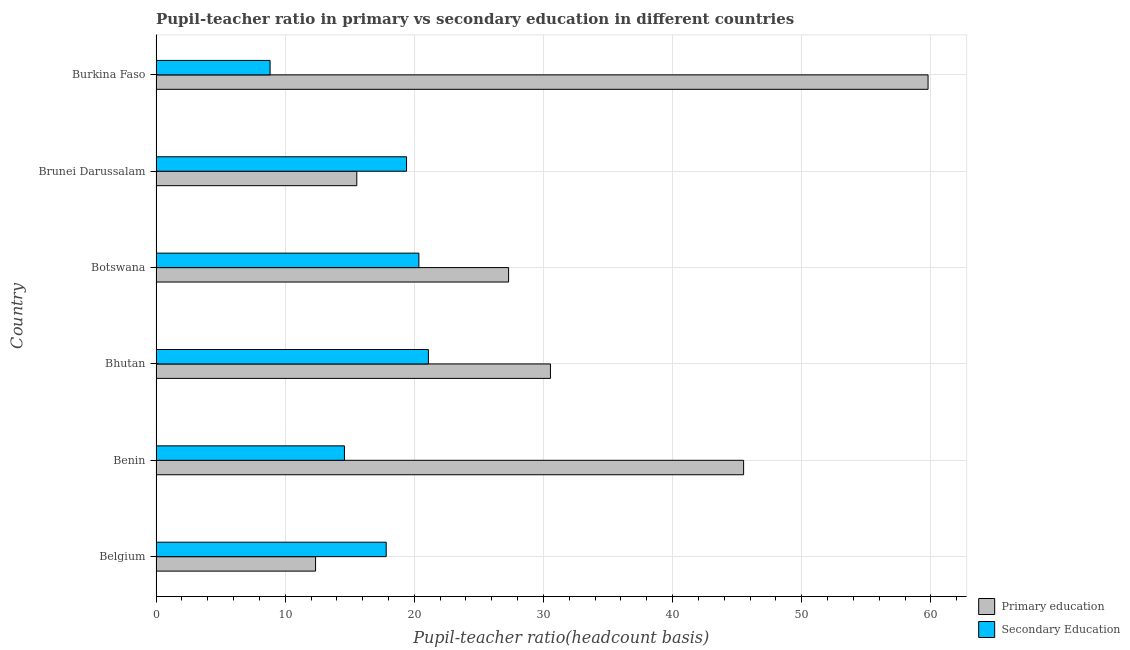Are the number of bars per tick equal to the number of legend labels?
Provide a succinct answer. Yes. Are the number of bars on each tick of the Y-axis equal?
Your response must be concise. Yes. How many bars are there on the 2nd tick from the top?
Make the answer very short. 2. What is the pupil teacher ratio on secondary education in Benin?
Keep it short and to the point. 14.59. Across all countries, what is the maximum pupil teacher ratio on secondary education?
Your response must be concise. 21.09. Across all countries, what is the minimum pupil teacher ratio on secondary education?
Provide a short and direct response. 8.83. In which country was the pupil-teacher ratio in primary education maximum?
Ensure brevity in your answer.  Burkina Faso. In which country was the pupil-teacher ratio in primary education minimum?
Keep it short and to the point. Belgium. What is the total pupil teacher ratio on secondary education in the graph?
Provide a succinct answer. 102.09. What is the difference between the pupil-teacher ratio in primary education in Bhutan and that in Brunei Darussalam?
Make the answer very short. 14.99. What is the difference between the pupil-teacher ratio in primary education in Botswana and the pupil teacher ratio on secondary education in Bhutan?
Offer a terse response. 6.21. What is the average pupil-teacher ratio in primary education per country?
Offer a very short reply. 31.84. What is the difference between the pupil teacher ratio on secondary education and pupil-teacher ratio in primary education in Bhutan?
Offer a terse response. -9.45. What is the ratio of the pupil teacher ratio on secondary education in Benin to that in Botswana?
Your answer should be compact. 0.72. Is the pupil teacher ratio on secondary education in Benin less than that in Brunei Darussalam?
Your answer should be compact. Yes. What is the difference between the highest and the second highest pupil-teacher ratio in primary education?
Offer a very short reply. 14.28. What is the difference between the highest and the lowest pupil-teacher ratio in primary education?
Provide a short and direct response. 47.43. Is the sum of the pupil-teacher ratio in primary education in Belgium and Benin greater than the maximum pupil teacher ratio on secondary education across all countries?
Offer a terse response. Yes. What does the 2nd bar from the top in Botswana represents?
Give a very brief answer. Primary education. What does the 2nd bar from the bottom in Belgium represents?
Your response must be concise. Secondary Education. What is the difference between two consecutive major ticks on the X-axis?
Provide a succinct answer. 10. Are the values on the major ticks of X-axis written in scientific E-notation?
Offer a very short reply. No. Does the graph contain any zero values?
Your response must be concise. No. What is the title of the graph?
Ensure brevity in your answer.  Pupil-teacher ratio in primary vs secondary education in different countries. What is the label or title of the X-axis?
Keep it short and to the point. Pupil-teacher ratio(headcount basis). What is the label or title of the Y-axis?
Give a very brief answer. Country. What is the Pupil-teacher ratio(headcount basis) of Primary education in Belgium?
Your response must be concise. 12.35. What is the Pupil-teacher ratio(headcount basis) in Secondary Education in Belgium?
Give a very brief answer. 17.82. What is the Pupil-teacher ratio(headcount basis) in Primary education in Benin?
Offer a very short reply. 45.5. What is the Pupil-teacher ratio(headcount basis) in Secondary Education in Benin?
Your answer should be compact. 14.59. What is the Pupil-teacher ratio(headcount basis) of Primary education in Bhutan?
Your response must be concise. 30.54. What is the Pupil-teacher ratio(headcount basis) of Secondary Education in Bhutan?
Make the answer very short. 21.09. What is the Pupil-teacher ratio(headcount basis) in Primary education in Botswana?
Provide a short and direct response. 27.3. What is the Pupil-teacher ratio(headcount basis) of Secondary Education in Botswana?
Your answer should be very brief. 20.35. What is the Pupil-teacher ratio(headcount basis) of Primary education in Brunei Darussalam?
Keep it short and to the point. 15.55. What is the Pupil-teacher ratio(headcount basis) of Secondary Education in Brunei Darussalam?
Give a very brief answer. 19.4. What is the Pupil-teacher ratio(headcount basis) of Primary education in Burkina Faso?
Provide a succinct answer. 59.78. What is the Pupil-teacher ratio(headcount basis) of Secondary Education in Burkina Faso?
Provide a succinct answer. 8.83. Across all countries, what is the maximum Pupil-teacher ratio(headcount basis) in Primary education?
Give a very brief answer. 59.78. Across all countries, what is the maximum Pupil-teacher ratio(headcount basis) of Secondary Education?
Your answer should be very brief. 21.09. Across all countries, what is the minimum Pupil-teacher ratio(headcount basis) in Primary education?
Your answer should be very brief. 12.35. Across all countries, what is the minimum Pupil-teacher ratio(headcount basis) in Secondary Education?
Give a very brief answer. 8.83. What is the total Pupil-teacher ratio(headcount basis) of Primary education in the graph?
Your answer should be compact. 191.01. What is the total Pupil-teacher ratio(headcount basis) of Secondary Education in the graph?
Make the answer very short. 102.09. What is the difference between the Pupil-teacher ratio(headcount basis) of Primary education in Belgium and that in Benin?
Your answer should be very brief. -33.14. What is the difference between the Pupil-teacher ratio(headcount basis) in Secondary Education in Belgium and that in Benin?
Keep it short and to the point. 3.23. What is the difference between the Pupil-teacher ratio(headcount basis) in Primary education in Belgium and that in Bhutan?
Offer a terse response. -18.19. What is the difference between the Pupil-teacher ratio(headcount basis) in Secondary Education in Belgium and that in Bhutan?
Your answer should be very brief. -3.27. What is the difference between the Pupil-teacher ratio(headcount basis) of Primary education in Belgium and that in Botswana?
Keep it short and to the point. -14.95. What is the difference between the Pupil-teacher ratio(headcount basis) in Secondary Education in Belgium and that in Botswana?
Make the answer very short. -2.53. What is the difference between the Pupil-teacher ratio(headcount basis) in Primary education in Belgium and that in Brunei Darussalam?
Offer a terse response. -3.19. What is the difference between the Pupil-teacher ratio(headcount basis) in Secondary Education in Belgium and that in Brunei Darussalam?
Keep it short and to the point. -1.58. What is the difference between the Pupil-teacher ratio(headcount basis) of Primary education in Belgium and that in Burkina Faso?
Make the answer very short. -47.43. What is the difference between the Pupil-teacher ratio(headcount basis) of Secondary Education in Belgium and that in Burkina Faso?
Your response must be concise. 8.99. What is the difference between the Pupil-teacher ratio(headcount basis) of Primary education in Benin and that in Bhutan?
Give a very brief answer. 14.96. What is the difference between the Pupil-teacher ratio(headcount basis) of Secondary Education in Benin and that in Bhutan?
Provide a short and direct response. -6.5. What is the difference between the Pupil-teacher ratio(headcount basis) in Primary education in Benin and that in Botswana?
Ensure brevity in your answer.  18.2. What is the difference between the Pupil-teacher ratio(headcount basis) in Secondary Education in Benin and that in Botswana?
Ensure brevity in your answer.  -5.76. What is the difference between the Pupil-teacher ratio(headcount basis) of Primary education in Benin and that in Brunei Darussalam?
Provide a short and direct response. 29.95. What is the difference between the Pupil-teacher ratio(headcount basis) of Secondary Education in Benin and that in Brunei Darussalam?
Keep it short and to the point. -4.81. What is the difference between the Pupil-teacher ratio(headcount basis) in Primary education in Benin and that in Burkina Faso?
Provide a succinct answer. -14.28. What is the difference between the Pupil-teacher ratio(headcount basis) in Secondary Education in Benin and that in Burkina Faso?
Your answer should be compact. 5.76. What is the difference between the Pupil-teacher ratio(headcount basis) in Primary education in Bhutan and that in Botswana?
Ensure brevity in your answer.  3.24. What is the difference between the Pupil-teacher ratio(headcount basis) in Secondary Education in Bhutan and that in Botswana?
Keep it short and to the point. 0.74. What is the difference between the Pupil-teacher ratio(headcount basis) in Primary education in Bhutan and that in Brunei Darussalam?
Your response must be concise. 14.99. What is the difference between the Pupil-teacher ratio(headcount basis) in Secondary Education in Bhutan and that in Brunei Darussalam?
Offer a terse response. 1.69. What is the difference between the Pupil-teacher ratio(headcount basis) of Primary education in Bhutan and that in Burkina Faso?
Your answer should be compact. -29.24. What is the difference between the Pupil-teacher ratio(headcount basis) of Secondary Education in Bhutan and that in Burkina Faso?
Your answer should be compact. 12.26. What is the difference between the Pupil-teacher ratio(headcount basis) of Primary education in Botswana and that in Brunei Darussalam?
Give a very brief answer. 11.75. What is the difference between the Pupil-teacher ratio(headcount basis) of Secondary Education in Botswana and that in Brunei Darussalam?
Provide a succinct answer. 0.96. What is the difference between the Pupil-teacher ratio(headcount basis) of Primary education in Botswana and that in Burkina Faso?
Keep it short and to the point. -32.48. What is the difference between the Pupil-teacher ratio(headcount basis) in Secondary Education in Botswana and that in Burkina Faso?
Provide a succinct answer. 11.52. What is the difference between the Pupil-teacher ratio(headcount basis) in Primary education in Brunei Darussalam and that in Burkina Faso?
Your answer should be compact. -44.23. What is the difference between the Pupil-teacher ratio(headcount basis) of Secondary Education in Brunei Darussalam and that in Burkina Faso?
Offer a terse response. 10.57. What is the difference between the Pupil-teacher ratio(headcount basis) of Primary education in Belgium and the Pupil-teacher ratio(headcount basis) of Secondary Education in Benin?
Ensure brevity in your answer.  -2.24. What is the difference between the Pupil-teacher ratio(headcount basis) in Primary education in Belgium and the Pupil-teacher ratio(headcount basis) in Secondary Education in Bhutan?
Provide a succinct answer. -8.74. What is the difference between the Pupil-teacher ratio(headcount basis) in Primary education in Belgium and the Pupil-teacher ratio(headcount basis) in Secondary Education in Botswana?
Provide a short and direct response. -8. What is the difference between the Pupil-teacher ratio(headcount basis) of Primary education in Belgium and the Pupil-teacher ratio(headcount basis) of Secondary Education in Brunei Darussalam?
Your answer should be very brief. -7.05. What is the difference between the Pupil-teacher ratio(headcount basis) in Primary education in Belgium and the Pupil-teacher ratio(headcount basis) in Secondary Education in Burkina Faso?
Your response must be concise. 3.52. What is the difference between the Pupil-teacher ratio(headcount basis) in Primary education in Benin and the Pupil-teacher ratio(headcount basis) in Secondary Education in Bhutan?
Provide a succinct answer. 24.41. What is the difference between the Pupil-teacher ratio(headcount basis) in Primary education in Benin and the Pupil-teacher ratio(headcount basis) in Secondary Education in Botswana?
Provide a succinct answer. 25.14. What is the difference between the Pupil-teacher ratio(headcount basis) of Primary education in Benin and the Pupil-teacher ratio(headcount basis) of Secondary Education in Brunei Darussalam?
Keep it short and to the point. 26.1. What is the difference between the Pupil-teacher ratio(headcount basis) in Primary education in Benin and the Pupil-teacher ratio(headcount basis) in Secondary Education in Burkina Faso?
Provide a short and direct response. 36.66. What is the difference between the Pupil-teacher ratio(headcount basis) in Primary education in Bhutan and the Pupil-teacher ratio(headcount basis) in Secondary Education in Botswana?
Your response must be concise. 10.19. What is the difference between the Pupil-teacher ratio(headcount basis) of Primary education in Bhutan and the Pupil-teacher ratio(headcount basis) of Secondary Education in Brunei Darussalam?
Offer a very short reply. 11.14. What is the difference between the Pupil-teacher ratio(headcount basis) of Primary education in Bhutan and the Pupil-teacher ratio(headcount basis) of Secondary Education in Burkina Faso?
Ensure brevity in your answer.  21.71. What is the difference between the Pupil-teacher ratio(headcount basis) in Primary education in Botswana and the Pupil-teacher ratio(headcount basis) in Secondary Education in Brunei Darussalam?
Ensure brevity in your answer.  7.9. What is the difference between the Pupil-teacher ratio(headcount basis) in Primary education in Botswana and the Pupil-teacher ratio(headcount basis) in Secondary Education in Burkina Faso?
Provide a succinct answer. 18.47. What is the difference between the Pupil-teacher ratio(headcount basis) in Primary education in Brunei Darussalam and the Pupil-teacher ratio(headcount basis) in Secondary Education in Burkina Faso?
Ensure brevity in your answer.  6.71. What is the average Pupil-teacher ratio(headcount basis) of Primary education per country?
Keep it short and to the point. 31.84. What is the average Pupil-teacher ratio(headcount basis) in Secondary Education per country?
Your response must be concise. 17.01. What is the difference between the Pupil-teacher ratio(headcount basis) in Primary education and Pupil-teacher ratio(headcount basis) in Secondary Education in Belgium?
Provide a short and direct response. -5.47. What is the difference between the Pupil-teacher ratio(headcount basis) of Primary education and Pupil-teacher ratio(headcount basis) of Secondary Education in Benin?
Make the answer very short. 30.91. What is the difference between the Pupil-teacher ratio(headcount basis) in Primary education and Pupil-teacher ratio(headcount basis) in Secondary Education in Bhutan?
Your answer should be very brief. 9.45. What is the difference between the Pupil-teacher ratio(headcount basis) of Primary education and Pupil-teacher ratio(headcount basis) of Secondary Education in Botswana?
Your answer should be compact. 6.95. What is the difference between the Pupil-teacher ratio(headcount basis) of Primary education and Pupil-teacher ratio(headcount basis) of Secondary Education in Brunei Darussalam?
Ensure brevity in your answer.  -3.85. What is the difference between the Pupil-teacher ratio(headcount basis) of Primary education and Pupil-teacher ratio(headcount basis) of Secondary Education in Burkina Faso?
Give a very brief answer. 50.95. What is the ratio of the Pupil-teacher ratio(headcount basis) in Primary education in Belgium to that in Benin?
Your response must be concise. 0.27. What is the ratio of the Pupil-teacher ratio(headcount basis) in Secondary Education in Belgium to that in Benin?
Your response must be concise. 1.22. What is the ratio of the Pupil-teacher ratio(headcount basis) of Primary education in Belgium to that in Bhutan?
Provide a succinct answer. 0.4. What is the ratio of the Pupil-teacher ratio(headcount basis) of Secondary Education in Belgium to that in Bhutan?
Your answer should be compact. 0.85. What is the ratio of the Pupil-teacher ratio(headcount basis) of Primary education in Belgium to that in Botswana?
Provide a succinct answer. 0.45. What is the ratio of the Pupil-teacher ratio(headcount basis) in Secondary Education in Belgium to that in Botswana?
Offer a terse response. 0.88. What is the ratio of the Pupil-teacher ratio(headcount basis) of Primary education in Belgium to that in Brunei Darussalam?
Ensure brevity in your answer.  0.79. What is the ratio of the Pupil-teacher ratio(headcount basis) of Secondary Education in Belgium to that in Brunei Darussalam?
Provide a short and direct response. 0.92. What is the ratio of the Pupil-teacher ratio(headcount basis) of Primary education in Belgium to that in Burkina Faso?
Provide a short and direct response. 0.21. What is the ratio of the Pupil-teacher ratio(headcount basis) of Secondary Education in Belgium to that in Burkina Faso?
Keep it short and to the point. 2.02. What is the ratio of the Pupil-teacher ratio(headcount basis) in Primary education in Benin to that in Bhutan?
Make the answer very short. 1.49. What is the ratio of the Pupil-teacher ratio(headcount basis) in Secondary Education in Benin to that in Bhutan?
Your response must be concise. 0.69. What is the ratio of the Pupil-teacher ratio(headcount basis) of Primary education in Benin to that in Botswana?
Your response must be concise. 1.67. What is the ratio of the Pupil-teacher ratio(headcount basis) of Secondary Education in Benin to that in Botswana?
Your answer should be compact. 0.72. What is the ratio of the Pupil-teacher ratio(headcount basis) in Primary education in Benin to that in Brunei Darussalam?
Offer a terse response. 2.93. What is the ratio of the Pupil-teacher ratio(headcount basis) in Secondary Education in Benin to that in Brunei Darussalam?
Make the answer very short. 0.75. What is the ratio of the Pupil-teacher ratio(headcount basis) in Primary education in Benin to that in Burkina Faso?
Your answer should be compact. 0.76. What is the ratio of the Pupil-teacher ratio(headcount basis) of Secondary Education in Benin to that in Burkina Faso?
Your answer should be compact. 1.65. What is the ratio of the Pupil-teacher ratio(headcount basis) in Primary education in Bhutan to that in Botswana?
Make the answer very short. 1.12. What is the ratio of the Pupil-teacher ratio(headcount basis) of Secondary Education in Bhutan to that in Botswana?
Your answer should be very brief. 1.04. What is the ratio of the Pupil-teacher ratio(headcount basis) in Primary education in Bhutan to that in Brunei Darussalam?
Make the answer very short. 1.96. What is the ratio of the Pupil-teacher ratio(headcount basis) of Secondary Education in Bhutan to that in Brunei Darussalam?
Make the answer very short. 1.09. What is the ratio of the Pupil-teacher ratio(headcount basis) in Primary education in Bhutan to that in Burkina Faso?
Provide a succinct answer. 0.51. What is the ratio of the Pupil-teacher ratio(headcount basis) of Secondary Education in Bhutan to that in Burkina Faso?
Offer a very short reply. 2.39. What is the ratio of the Pupil-teacher ratio(headcount basis) in Primary education in Botswana to that in Brunei Darussalam?
Offer a very short reply. 1.76. What is the ratio of the Pupil-teacher ratio(headcount basis) in Secondary Education in Botswana to that in Brunei Darussalam?
Offer a very short reply. 1.05. What is the ratio of the Pupil-teacher ratio(headcount basis) of Primary education in Botswana to that in Burkina Faso?
Keep it short and to the point. 0.46. What is the ratio of the Pupil-teacher ratio(headcount basis) of Secondary Education in Botswana to that in Burkina Faso?
Offer a terse response. 2.3. What is the ratio of the Pupil-teacher ratio(headcount basis) in Primary education in Brunei Darussalam to that in Burkina Faso?
Your answer should be very brief. 0.26. What is the ratio of the Pupil-teacher ratio(headcount basis) of Secondary Education in Brunei Darussalam to that in Burkina Faso?
Your answer should be very brief. 2.2. What is the difference between the highest and the second highest Pupil-teacher ratio(headcount basis) of Primary education?
Keep it short and to the point. 14.28. What is the difference between the highest and the second highest Pupil-teacher ratio(headcount basis) of Secondary Education?
Your answer should be very brief. 0.74. What is the difference between the highest and the lowest Pupil-teacher ratio(headcount basis) of Primary education?
Keep it short and to the point. 47.43. What is the difference between the highest and the lowest Pupil-teacher ratio(headcount basis) in Secondary Education?
Provide a succinct answer. 12.26. 